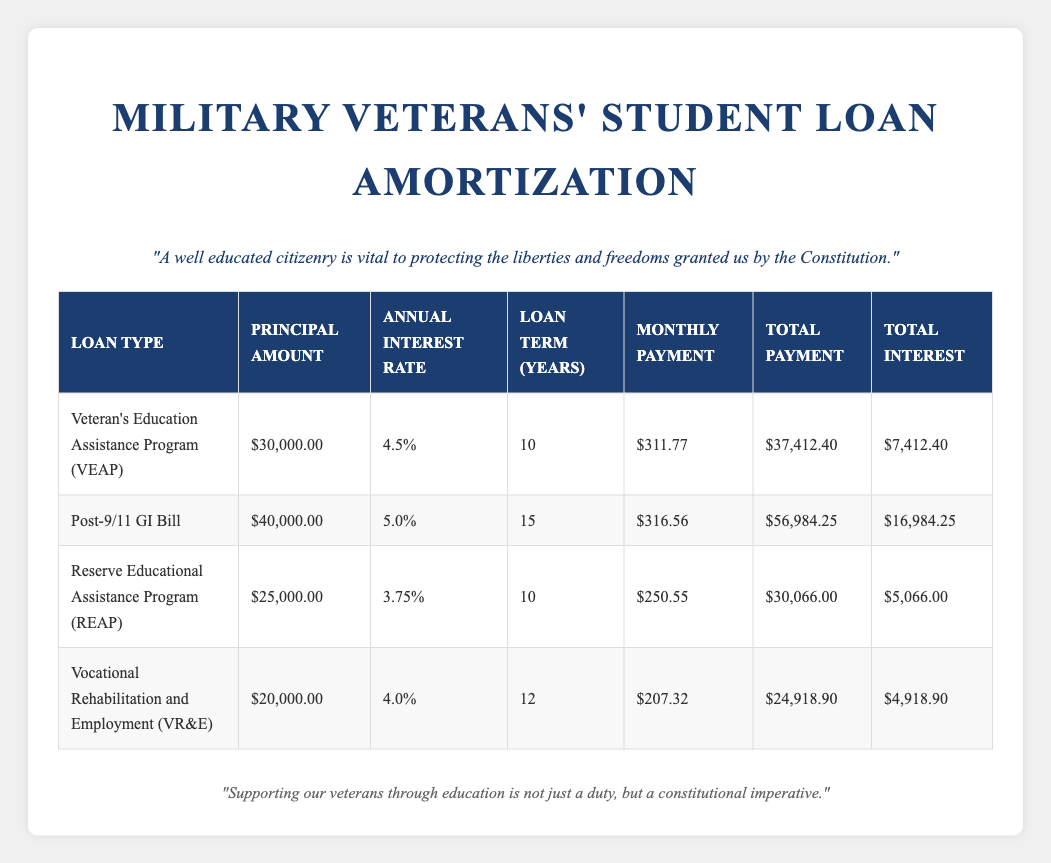What is the principal amount for the Post-9/11 GI Bill? The principal amount is directly listed in the row for the Post-9/11 GI Bill in the table. It states that the principal amount is $40,000.00.
Answer: $40,000.00 Which loan has the highest total interest? To find the highest total interest, I look across the total interest column. The Post-9/11 GI Bill shows a total interest of $16,984.25, which is greater than all other loans listed.
Answer: $16,984.25 Is the annual interest rate for the Reserve Educational Assistance Program higher than 4%? The annual interest rate for the Reserve Educational Assistance Program is listed as 3.75%, which is lower than 4%. Therefore, the statement is false.
Answer: No What is the total payment for the Veteran's Education Assistance Program (VEAP)? Looking at the VEAP row, the total payment is clearly stated as $37,412.40. This value is part of the data provided.
Answer: $37,412.40 If I consolidate the loans from both the Vocational Rehabilitation and Employment (VR&E) and the Reserve Educational Assistance Program (REAP), what would be the combined principal amount? The principal amount for VR&E is $20,000.00 and for REAP it is $25,000.00. Adding these amounts gives $20,000.00 + $25,000.00 = $45,000.00.
Answer: $45,000.00 Which loan type has the longest loan term? By examining the loan term column, the Post-9/11 GI Bill has the longest loan term of 15 years when compared to the other loans.
Answer: Post-9/11 GI Bill What is the average monthly payment for all the loans? To find the average monthly payment, I add all monthly payments: (311.77 + 316.56 + 250.55 + 207.32) = 1086.20. Then, divide by the number of loans (4): 1086.20 / 4 = 271.55.
Answer: 271.55 Do all loans have a total payment amount greater than $25,000? Checking the total payment column: VEAP has $37,412.40, Post-9/11 GI Bill has $56,984.25, REAP has $30,066.00, and VR&E has $24,918.90. The last value is less than $25,000, making the statement false.
Answer: No What is the difference in total payment between the Post-9/11 GI Bill and the Vocational Rehabilitation and Employment (VR&E)? The total payment for Post-9/11 GI Bill is $56,984.25 and for VR&E is $24,918.90. The difference is $56,984.25 - $24,918.90 = $32,065.35.
Answer: $32,065.35 